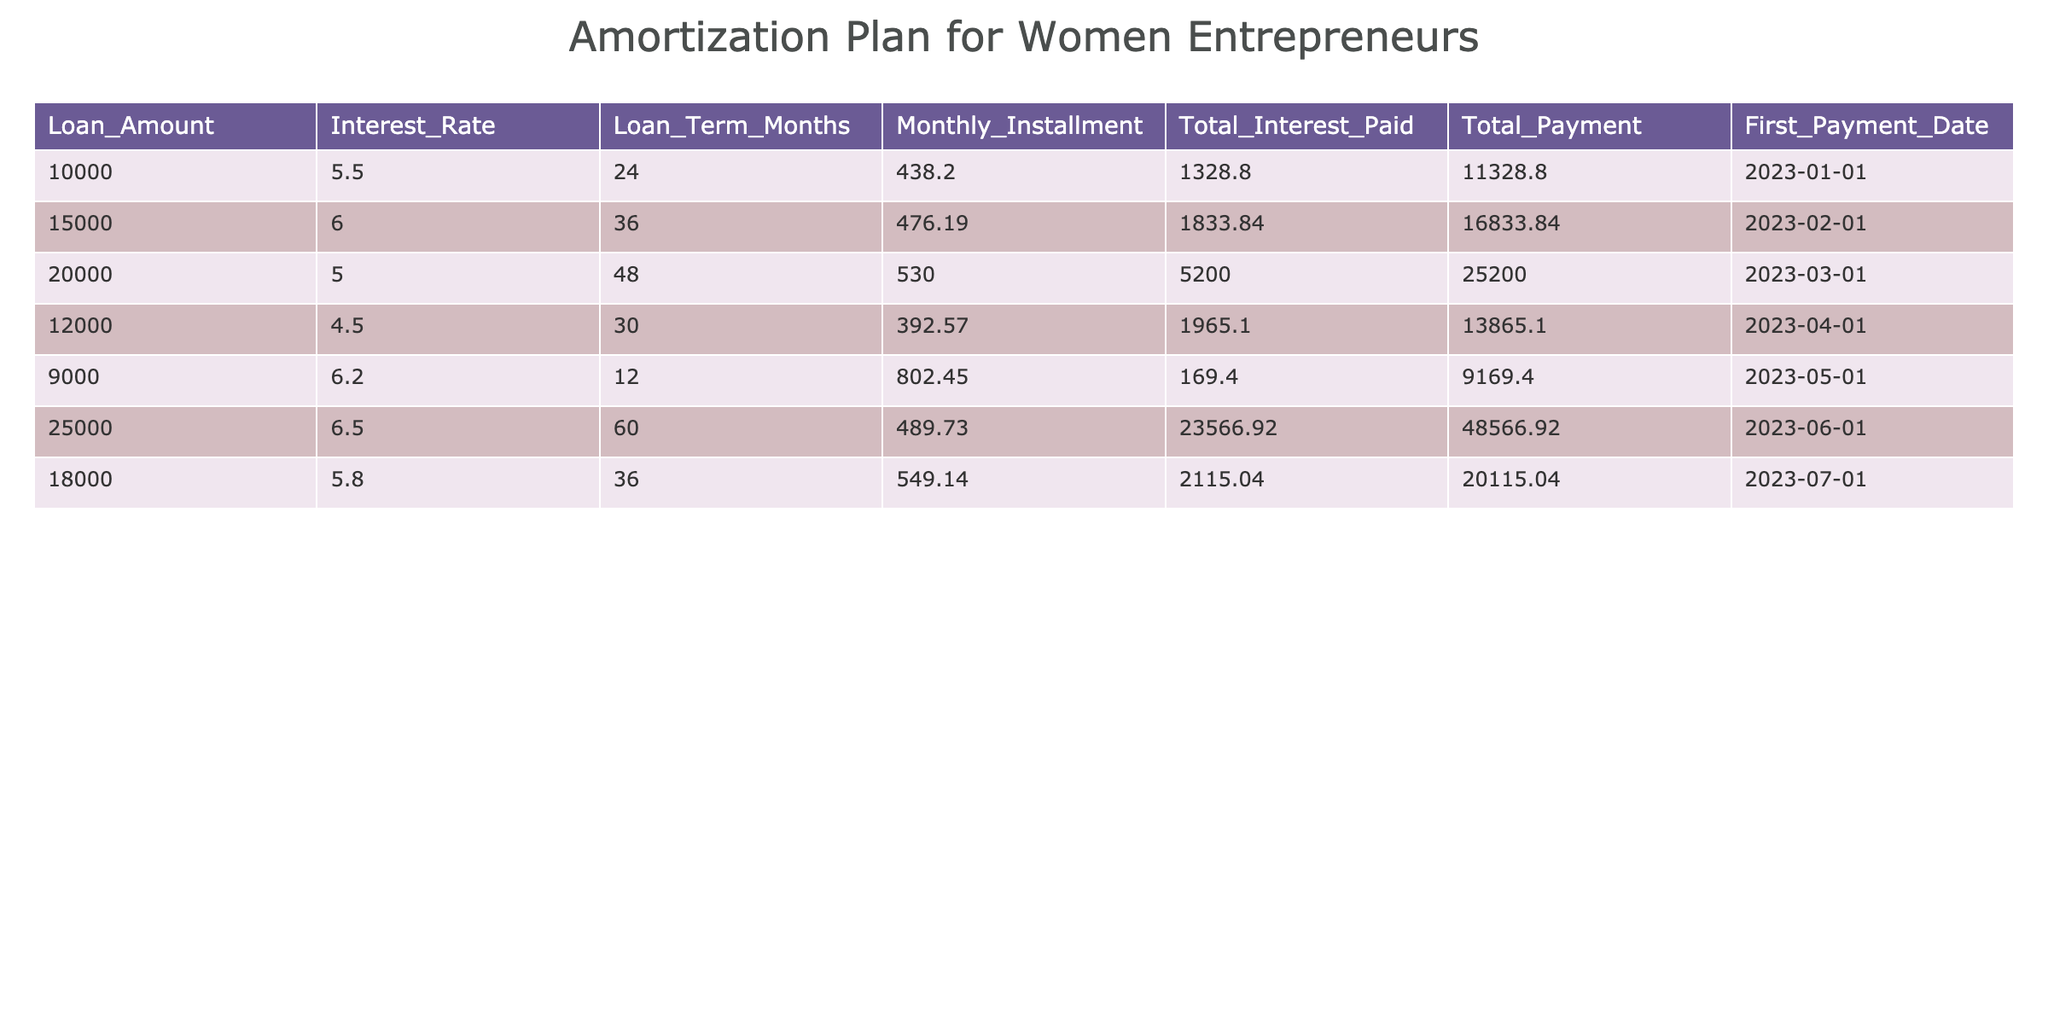What is the loan amount for the highest monthly installment? Looking at the table, the highest monthly installment is 802.45, which corresponds to the loan amount of 9000.
Answer: 9000 What is the total payment for the loan with a term of 60 months? The loan with a term of 60 months is 25000, and the total payment for it is 48566.92.
Answer: 48566.92 What is the average total interest paid across all loans? To find the average total interest paid, we sum the total interest amounts (1328.80 + 1833.84 + 5200.00 + 1965.10 + 169.40 + 23566.92 + 2115.04) which equals 30979.10. Then, dividing by the number of loans (7), we get 30979.10 / 7 = 4425.87.
Answer: 4425.87 Is there a loan with an interest rate higher than 6.5%? Checking the table, the maximum interest rate listed is 6.5%, therefore there is no loan with an interest rate higher than this value.
Answer: No What is the difference in total payment between the loan of 15000 and the loan of 12000? The total payment for the loan of 15000 is 16833.84, while for the loan of 12000 it is 13865.10. The difference is 16833.84 - 13865.10 = 2968.74.
Answer: 2968.74 What is the total monthly installment of all loans combined? To find the total monthly installment, we sum all the monthly installments: (438.20 + 476.19 + 530.00 + 392.57 + 802.45 + 489.73 + 549.14) = 3178.28.
Answer: 3178.28 Are there more loans with terms longer than 36 months than those shorter than 24 months? Examining the table, there are 4 loans greater than 36 months and only 1 loan shorter than 24 months. Therefore, the statement is true.
Answer: Yes What is the total interest paid for the loan that was taken out on 2023-07-01? The loan taken on 2023-07-01 has a total interest of 2115.04.
Answer: 2115.04 